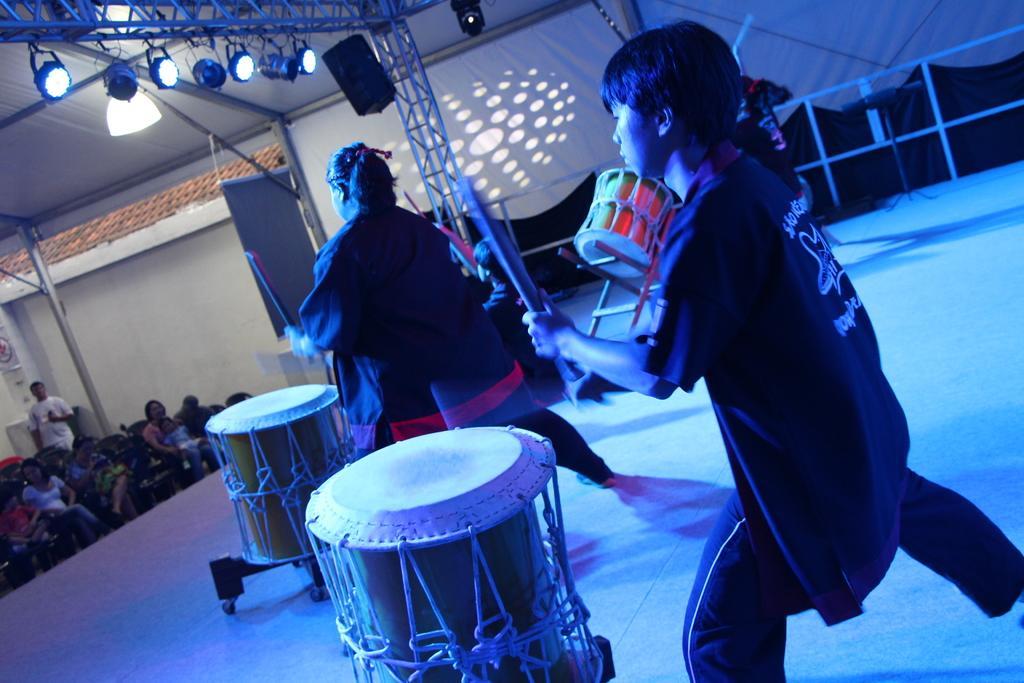Can you describe this image briefly? There are a three people on a stage. They are playing a snare drum with drum sticks. Here we can see a few people who are sitting on a chair and watching these people. 